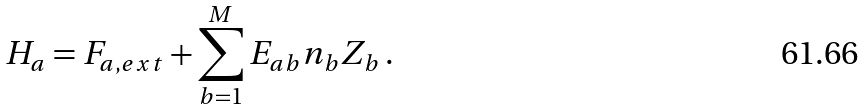<formula> <loc_0><loc_0><loc_500><loc_500>H _ { a } = F _ { a , e x t } + \sum _ { b = 1 } ^ { M } E _ { a b } n _ { b } Z _ { b } \, .</formula> 